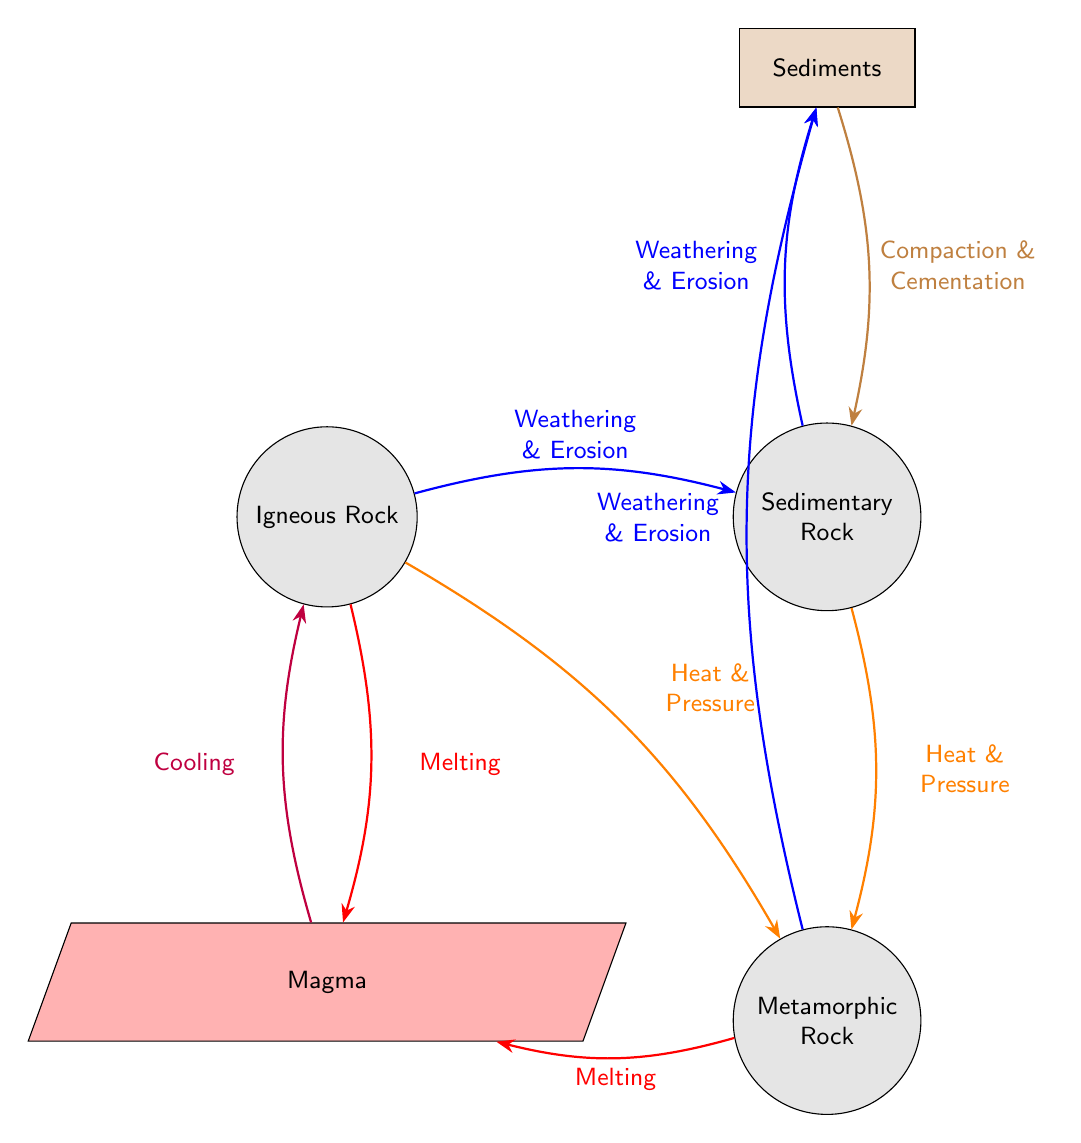What type of rock is formed from cooling magma? The diagram indicates that cooling magma transforms into Igneous Rock, as shown by the arrow labeled "Cooling" leading to the Igneous Rock node from the Magma node.
Answer: Igneous Rock How many transformations are shown between the rocks? Counting the arrows representing processes, there are a total of four transformations: from igneous to sedimentary, sedimentary to metamorphic, metamorphic to magma, and magma back to igneous.
Answer: Four What process leads to the formation of Sedimentary Rock? According to the diagram, Sedimentary Rock is formed through "Weathering & Erosion" which is illustrated by the connection from Igneous Rock to Sedimentary Rock with that label.
Answer: Weathering & Erosion Which type of rock results from "Heat & Pressure"? The diagram shows that "Heat & Pressure" transforms Sedimentary Rock into Metamorphic Rock, with the corresponding arrow depicting this process from the Sedimentary Rock node to the Metamorphic Rock node.
Answer: Metamorphic Rock What materials are involved in the formation of Sediments? The diagram indicates that Sediments are formed through the processes of "Weathering & Erosion" as depicted by the connection from Metamorphic Rock to Sediments.
Answer: Weathering & Erosion What is the last step before forming Igneous Rock? The last step illustrated before reaching Igneous Rock is the process labeled "Cooling," which takes place as magma solidifies into igneous rock, evident from the arrow pointing from the Magma node to the Igneous Rock node.
Answer: Cooling From which type of rock does "Melting" occur? The diagram specifies that "Melting" occurs with Igneous Rock transforming into Magma, as evidenced by the process label pointing from the Igneous Rock node to the Magma node.
Answer: Igneous Rock How many types of rocks are represented in the diagram? There are three distinct types of rocks represented in the diagram: Igneous Rock, Sedimentary Rock, and Metamorphic Rock, totaling three.
Answer: Three 